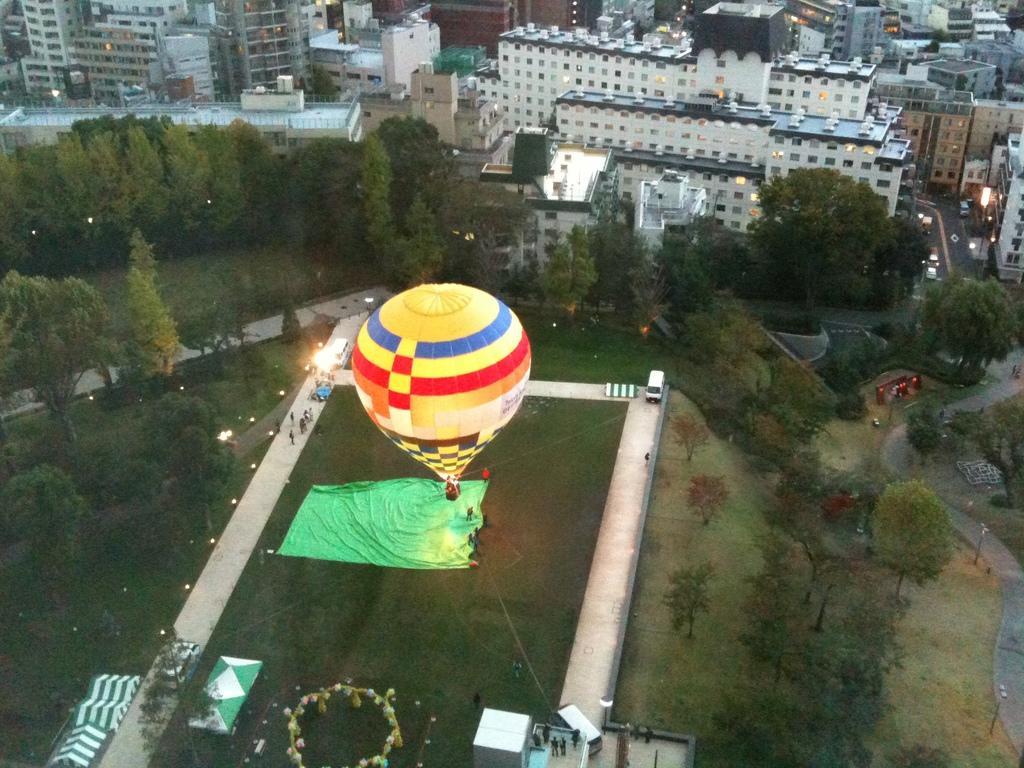Please provide a concise description of this image. In this image, I can see a hot air balloon, which is tied with the ropes. There are buildings, trees, plants, vehicles, lights and groups of people. On the right side of the image, there is a pathway. 